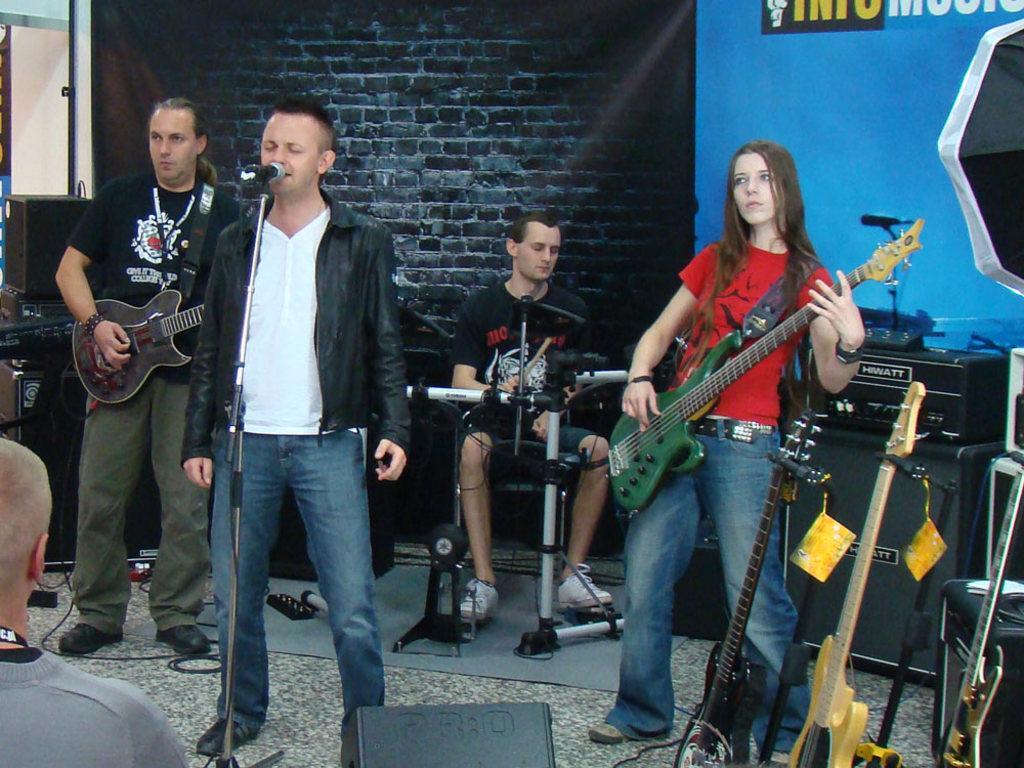How would you summarize this image in a sentence or two? On the background we can see window, wall with bricks and a banner. We can see persons standing here and playing guitar. We can see a man standing in front of a mike and singing. Behind to this man we can see a man sitting and playing drums. These are guitars. This is a device. 